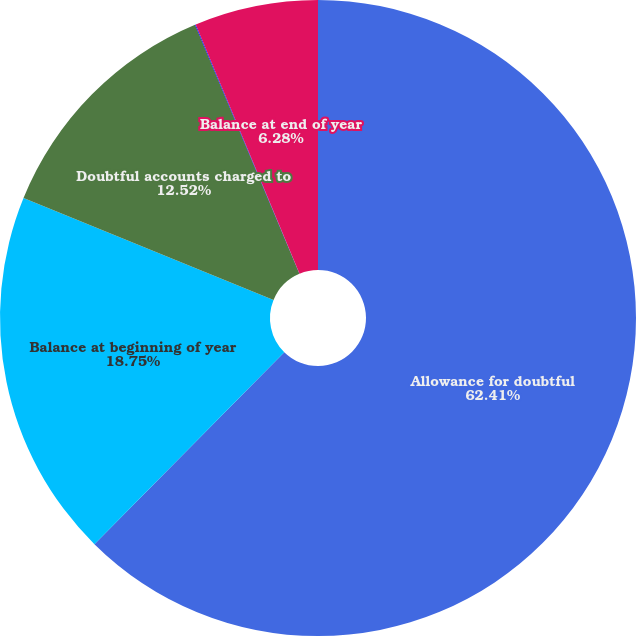Convert chart to OTSL. <chart><loc_0><loc_0><loc_500><loc_500><pie_chart><fcel>Allowance for doubtful<fcel>Balance at beginning of year<fcel>Doubtful accounts charged to<fcel>Currency translation<fcel>Balance at end of year<nl><fcel>62.41%<fcel>18.75%<fcel>12.52%<fcel>0.04%<fcel>6.28%<nl></chart> 